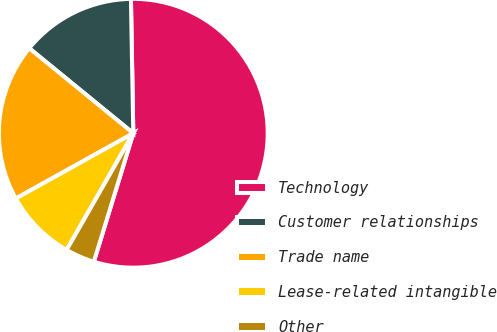Convert chart to OTSL. <chart><loc_0><loc_0><loc_500><loc_500><pie_chart><fcel>Technology<fcel>Customer relationships<fcel>Trade name<fcel>Lease-related intangible<fcel>Other<nl><fcel>55.02%<fcel>13.82%<fcel>18.97%<fcel>8.67%<fcel>3.52%<nl></chart> 